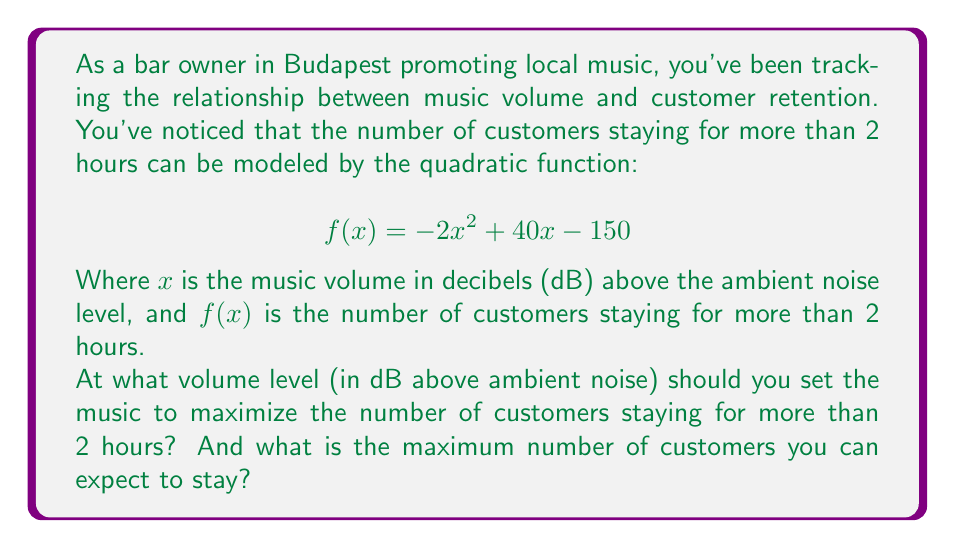Teach me how to tackle this problem. To solve this problem, we need to find the vertex of the parabola represented by the quadratic function. The vertex will give us the maximum point of the function.

For a quadratic function in the form $f(x) = ax^2 + bx + c$, the x-coordinate of the vertex is given by $x = -\frac{b}{2a}$.

In our case, $a = -2$, $b = 40$, and $c = -150$.

1) Calculate the x-coordinate of the vertex:
   $$ x = -\frac{b}{2a} = -\frac{40}{2(-2)} = -\frac{40}{-4} = 10 $$

2) To find the maximum number of customers (y-coordinate of the vertex), we substitute x = 10 into the original function:

   $$ f(10) = -2(10)^2 + 40(10) - 150 $$
   $$ = -2(100) + 400 - 150 $$
   $$ = -200 + 400 - 150 $$
   $$ = 50 $$

Therefore, the music should be set to 10 dB above the ambient noise level to maximize customer retention, and at this level, we can expect 50 customers to stay for more than 2 hours.
Answer: The optimal volume is 10 dB above ambient noise level, resulting in a maximum of 50 customers staying for more than 2 hours. 